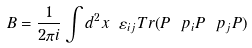<formula> <loc_0><loc_0><loc_500><loc_500>B = \frac { 1 } { 2 \pi i } \int d ^ { 2 } x \ \varepsilon _ { i j } T r ( P \ p _ { i } P \ p _ { j } P )</formula> 